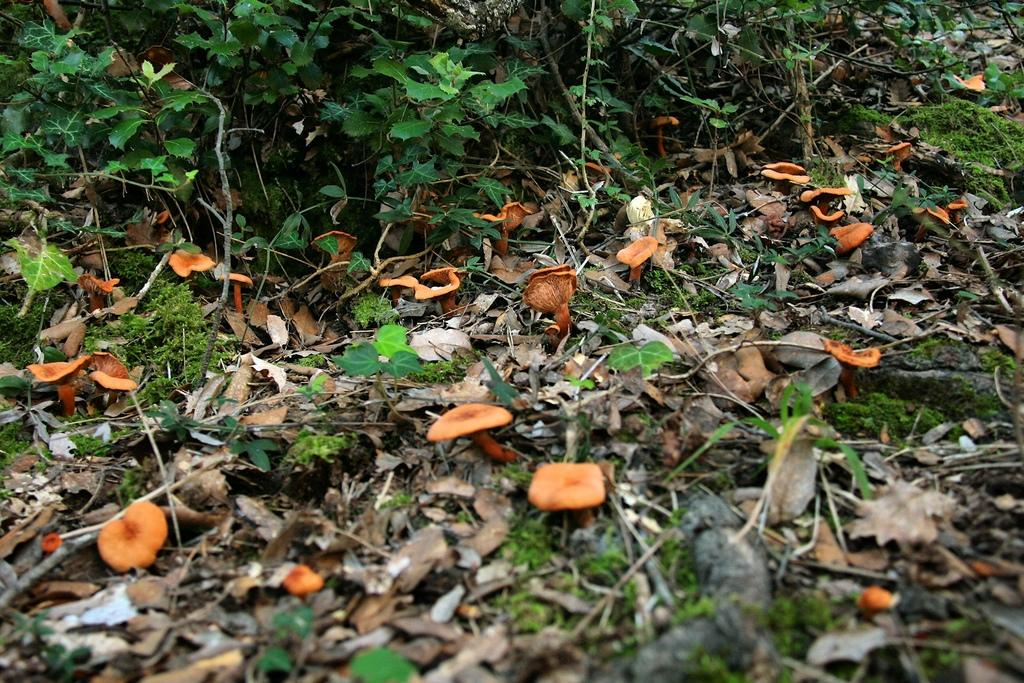What type of vegetation can be seen in the image? There are dried leaves, grass, mushrooms, and plants in the image. Can you describe the different types of plants in the image? The image contains dried leaves, grass, mushrooms, and other plants. What is the primary color of the vegetation in the image? The primary color of the vegetation in the image is green, as seen in the grass and plants. What is the angle of the argument between the mushrooms in the image? There is no argument present in the image, as it features vegetation such as dried leaves, grass, mushrooms, and plants. 